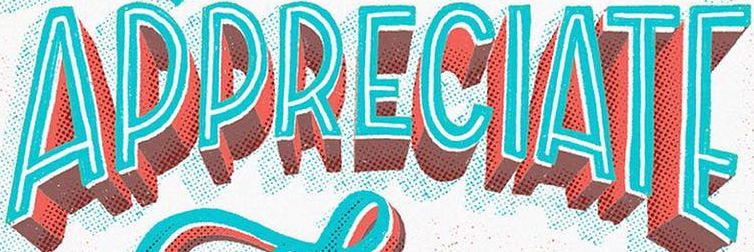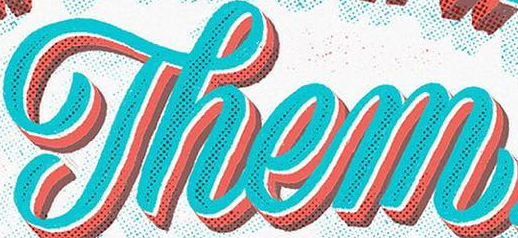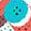Transcribe the words shown in these images in order, separated by a semicolon. APPRECIATE; Them; . 